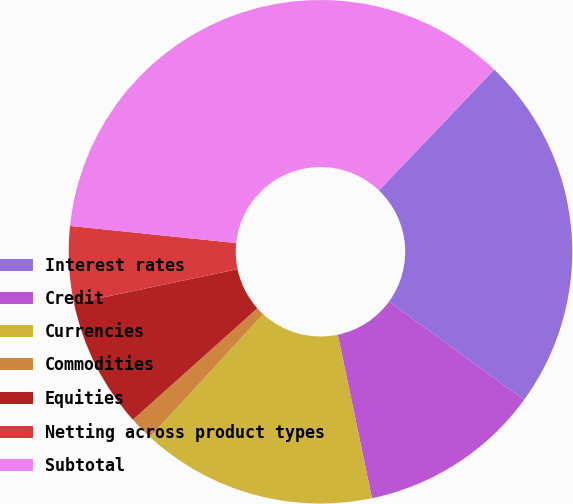Convert chart to OTSL. <chart><loc_0><loc_0><loc_500><loc_500><pie_chart><fcel>Interest rates<fcel>Credit<fcel>Currencies<fcel>Commodities<fcel>Equities<fcel>Netting across product types<fcel>Subtotal<nl><fcel>22.88%<fcel>11.72%<fcel>15.12%<fcel>1.54%<fcel>8.33%<fcel>4.93%<fcel>35.49%<nl></chart> 